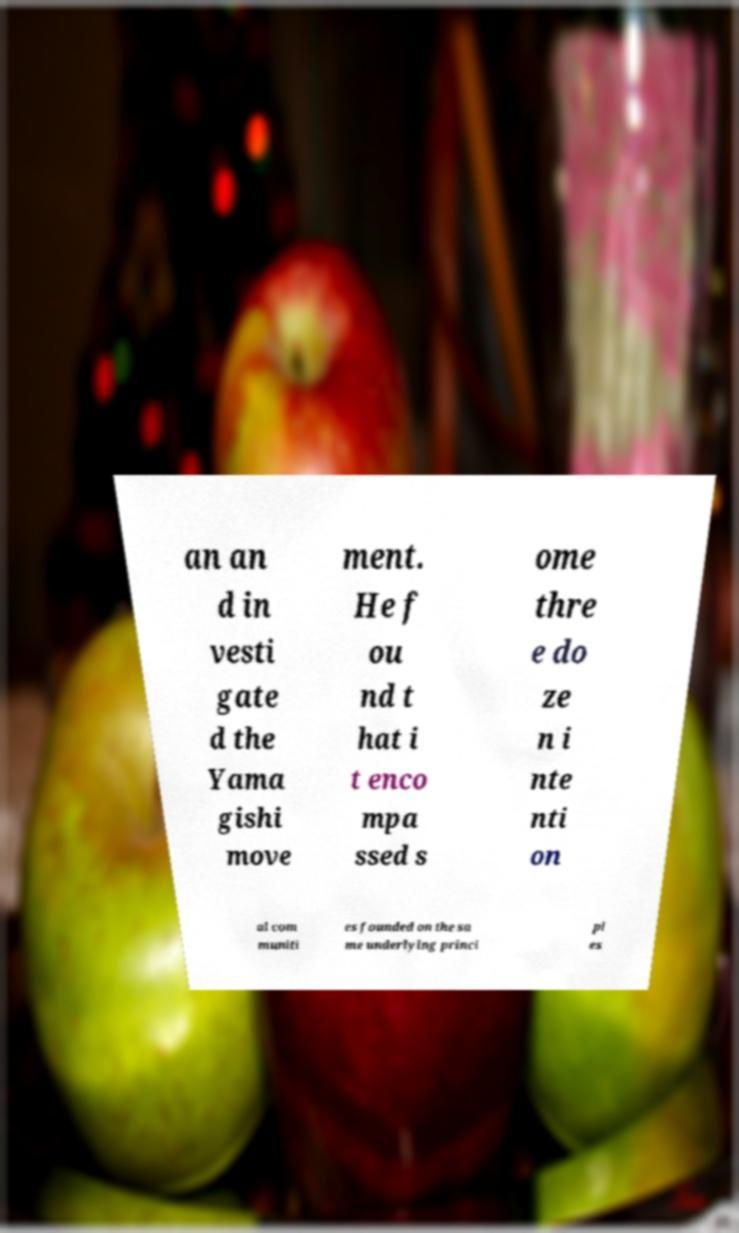What messages or text are displayed in this image? I need them in a readable, typed format. an an d in vesti gate d the Yama gishi move ment. He f ou nd t hat i t enco mpa ssed s ome thre e do ze n i nte nti on al com muniti es founded on the sa me underlying princi pl es 